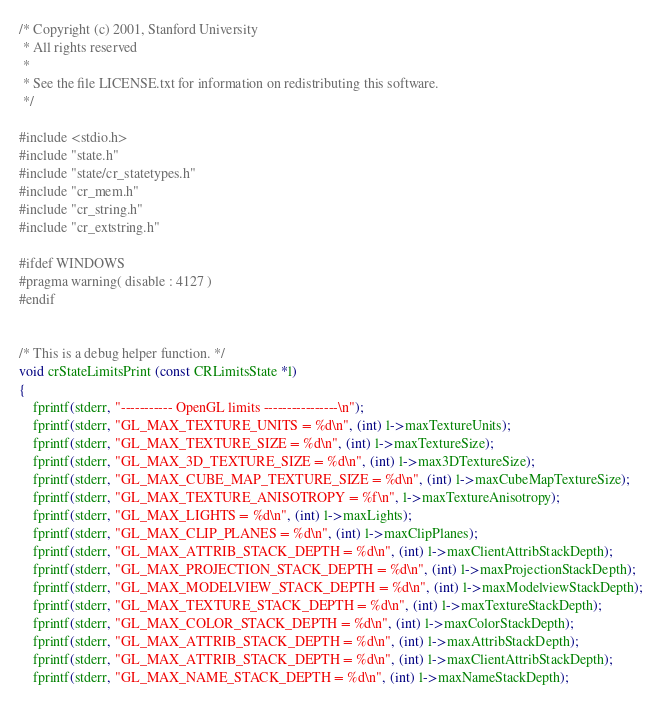Convert code to text. <code><loc_0><loc_0><loc_500><loc_500><_C_>
/* Copyright (c) 2001, Stanford University
 * All rights reserved
 *
 * See the file LICENSE.txt for information on redistributing this software.
 */

#include <stdio.h>
#include "state.h"
#include "state/cr_statetypes.h"
#include "cr_mem.h"
#include "cr_string.h"
#include "cr_extstring.h"

#ifdef WINDOWS
#pragma warning( disable : 4127 )
#endif


/* This is a debug helper function. */
void crStateLimitsPrint (const CRLimitsState *l)
{
	fprintf(stderr, "----------- OpenGL limits ----------------\n");
	fprintf(stderr, "GL_MAX_TEXTURE_UNITS = %d\n", (int) l->maxTextureUnits);
	fprintf(stderr, "GL_MAX_TEXTURE_SIZE = %d\n", (int) l->maxTextureSize);
	fprintf(stderr, "GL_MAX_3D_TEXTURE_SIZE = %d\n", (int) l->max3DTextureSize);
	fprintf(stderr, "GL_MAX_CUBE_MAP_TEXTURE_SIZE = %d\n", (int) l->maxCubeMapTextureSize);
	fprintf(stderr, "GL_MAX_TEXTURE_ANISOTROPY = %f\n", l->maxTextureAnisotropy);
	fprintf(stderr, "GL_MAX_LIGHTS = %d\n", (int) l->maxLights);
	fprintf(stderr, "GL_MAX_CLIP_PLANES = %d\n", (int) l->maxClipPlanes);
	fprintf(stderr, "GL_MAX_ATTRIB_STACK_DEPTH = %d\n", (int) l->maxClientAttribStackDepth);
	fprintf(stderr, "GL_MAX_PROJECTION_STACK_DEPTH = %d\n", (int) l->maxProjectionStackDepth);
	fprintf(stderr, "GL_MAX_MODELVIEW_STACK_DEPTH = %d\n", (int) l->maxModelviewStackDepth);
	fprintf(stderr, "GL_MAX_TEXTURE_STACK_DEPTH = %d\n", (int) l->maxTextureStackDepth);
	fprintf(stderr, "GL_MAX_COLOR_STACK_DEPTH = %d\n", (int) l->maxColorStackDepth);
	fprintf(stderr, "GL_MAX_ATTRIB_STACK_DEPTH = %d\n", (int) l->maxAttribStackDepth);
	fprintf(stderr, "GL_MAX_ATTRIB_STACK_DEPTH = %d\n", (int) l->maxClientAttribStackDepth);
	fprintf(stderr, "GL_MAX_NAME_STACK_DEPTH = %d\n", (int) l->maxNameStackDepth);</code> 